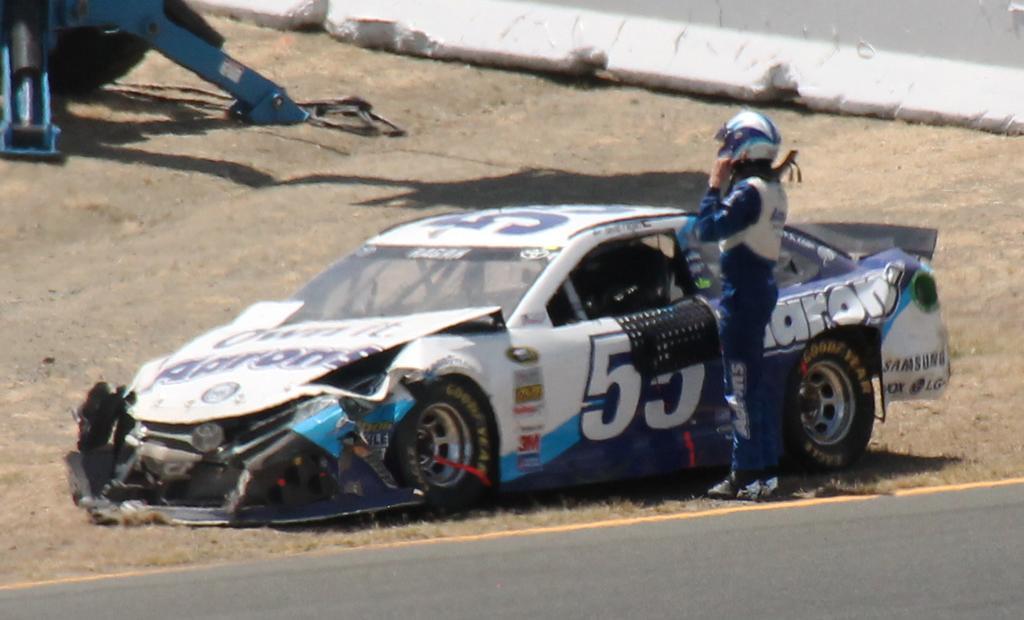Describe this image in one or two sentences. In the center of the image there is a road, one car and one person is standing and wearing a helmet. In the background there is a wall, one blue color object and grass. 